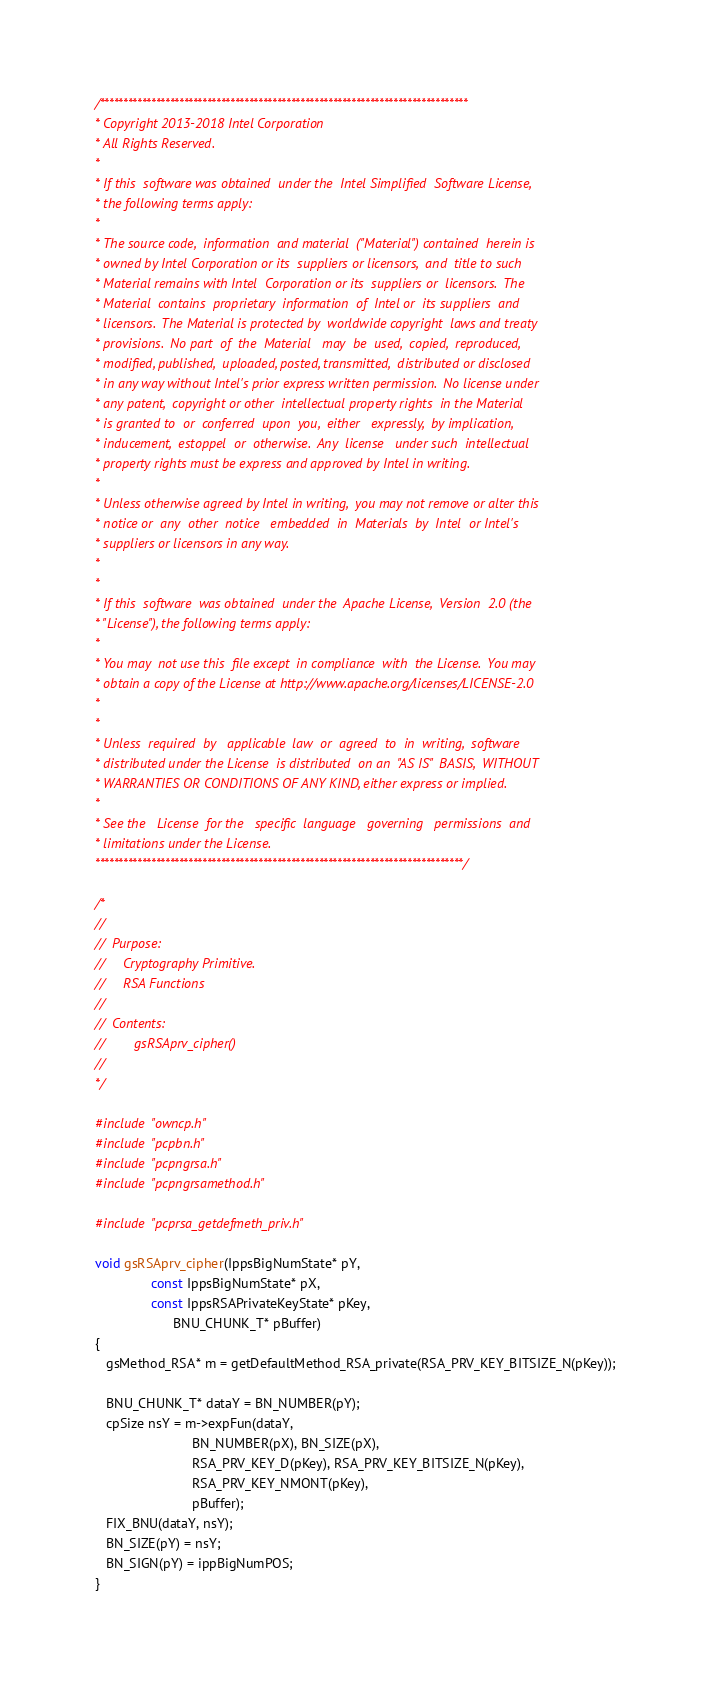<code> <loc_0><loc_0><loc_500><loc_500><_C_>/*******************************************************************************
* Copyright 2013-2018 Intel Corporation
* All Rights Reserved.
*
* If this  software was obtained  under the  Intel Simplified  Software License,
* the following terms apply:
*
* The source code,  information  and material  ("Material") contained  herein is
* owned by Intel Corporation or its  suppliers or licensors,  and  title to such
* Material remains with Intel  Corporation or its  suppliers or  licensors.  The
* Material  contains  proprietary  information  of  Intel or  its suppliers  and
* licensors.  The Material is protected by  worldwide copyright  laws and treaty
* provisions.  No part  of  the  Material   may  be  used,  copied,  reproduced,
* modified, published,  uploaded, posted, transmitted,  distributed or disclosed
* in any way without Intel's prior express written permission.  No license under
* any patent,  copyright or other  intellectual property rights  in the Material
* is granted to  or  conferred  upon  you,  either   expressly,  by implication,
* inducement,  estoppel  or  otherwise.  Any  license   under such  intellectual
* property rights must be express and approved by Intel in writing.
*
* Unless otherwise agreed by Intel in writing,  you may not remove or alter this
* notice or  any  other  notice   embedded  in  Materials  by  Intel  or Intel's
* suppliers or licensors in any way.
*
*
* If this  software  was obtained  under the  Apache License,  Version  2.0 (the
* "License"), the following terms apply:
*
* You may  not use this  file except  in compliance  with  the License.  You may
* obtain a copy of the License at http://www.apache.org/licenses/LICENSE-2.0
*
*
* Unless  required  by   applicable  law  or  agreed  to  in  writing,  software
* distributed under the License  is distributed  on an  "AS IS"  BASIS,  WITHOUT
* WARRANTIES OR CONDITIONS OF ANY KIND, either express or implied.
*
* See the   License  for the   specific  language   governing   permissions  and
* limitations under the License.
*******************************************************************************/

/* 
// 
//  Purpose:
//     Cryptography Primitive.
//     RSA Functions
// 
//  Contents:
//        gsRSAprv_cipher()
//
*/

#include "owncp.h"
#include "pcpbn.h"
#include "pcpngrsa.h"
#include "pcpngrsamethod.h"

#include "pcprsa_getdefmeth_priv.h"

void gsRSAprv_cipher(IppsBigNumState* pY,
               const IppsBigNumState* pX,
               const IppsRSAPrivateKeyState* pKey,
                     BNU_CHUNK_T* pBuffer)
{
   gsMethod_RSA* m = getDefaultMethod_RSA_private(RSA_PRV_KEY_BITSIZE_N(pKey));

   BNU_CHUNK_T* dataY = BN_NUMBER(pY);
   cpSize nsY = m->expFun(dataY,
                          BN_NUMBER(pX), BN_SIZE(pX),
                          RSA_PRV_KEY_D(pKey), RSA_PRV_KEY_BITSIZE_N(pKey),
                          RSA_PRV_KEY_NMONT(pKey),
                          pBuffer);
   FIX_BNU(dataY, nsY);
   BN_SIZE(pY) = nsY;
   BN_SIGN(pY) = ippBigNumPOS;
}
</code> 